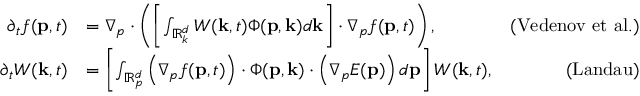<formula> <loc_0><loc_0><loc_500><loc_500>\begin{array} { r l r } { \partial _ { t } f ( p , t ) } & { = \nabla _ { p } \cdot \left ( \left [ \int _ { \mathbb { R } _ { k } ^ { d } } W ( k , t ) \Phi ( p , k ) d k \right ] \cdot \nabla _ { p } f ( p , t ) \right ) , } & { ( V e d e n o v e t a l . ) } \\ { \partial _ { t } W ( k , t ) } & { = \left [ \int _ { \mathbb { R } _ { p } ^ { d } } \left ( \nabla _ { p } f ( p , t ) \right ) \cdot \Phi ( p , k ) \cdot \left ( \nabla _ { p } E ( p ) \right ) d p \right ] W ( k , t ) , } & { ( L a n d a u ) } \end{array}</formula> 